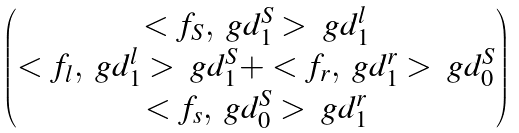Convert formula to latex. <formula><loc_0><loc_0><loc_500><loc_500>\begin{pmatrix} < f _ { S } , \ g d ^ { S } _ { 1 } > \ g d ^ { l } _ { 1 } \\ < f _ { l } , \ g d ^ { l } _ { 1 } > \ g d ^ { S } _ { 1 } + < f _ { r } , \ g d ^ { r } _ { 1 } > \ g d ^ { S } _ { 0 } \\ < f _ { s } , \ g d ^ { S } _ { 0 } > \ g d ^ { r } _ { 1 } \end{pmatrix}</formula> 